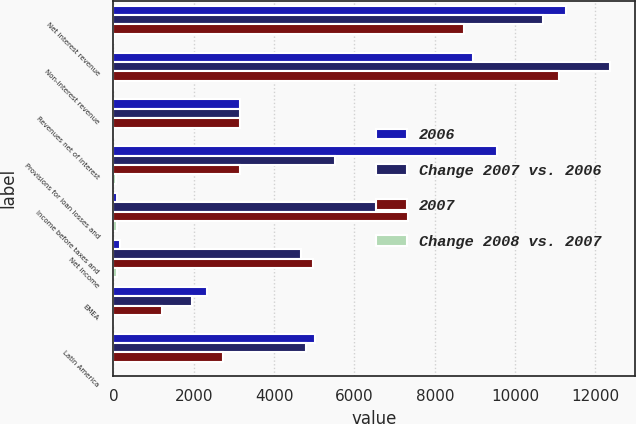Convert chart to OTSL. <chart><loc_0><loc_0><loc_500><loc_500><stacked_bar_chart><ecel><fcel>Net interest revenue<fcel>Non-interest revenue<fcel>Revenues net of interest<fcel>Provisions for loan losses and<fcel>Income before taxes and<fcel>Net income<fcel>EMEA<fcel>Latin America<nl><fcel>2006<fcel>11267<fcel>8940<fcel>3152<fcel>9556<fcel>95<fcel>166<fcel>2326<fcel>5017<nl><fcel>Change 2007 vs. 2006<fcel>10682<fcel>12369<fcel>3152<fcel>5517<fcel>6963<fcel>4674<fcel>1955<fcel>4803<nl><fcel>2007<fcel>8725<fcel>11087<fcel>3152<fcel>3152<fcel>7336<fcel>4978<fcel>1205<fcel>2726<nl><fcel>Change 2008 vs. 2007<fcel>5<fcel>28<fcel>12<fcel>73<fcel>99<fcel>96<fcel>19<fcel>4<nl></chart> 